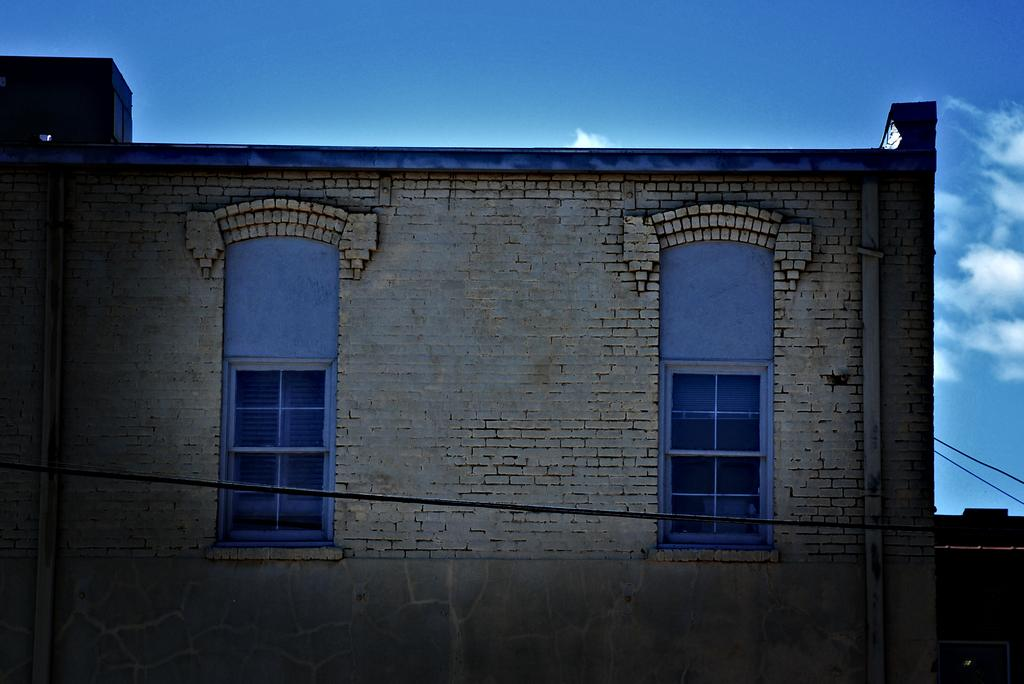What type of structure is visible in the image? There is a building with windows in the image. What can be seen in the background of the image? The sky is visible in the background of the image. Can you describe the object on the right side of the image? Unfortunately, the provided facts do not give enough information to describe the object on the right side of the image. How many giants can be seen walking in the image? There are no giants present in the image. What type of drop can be seen falling from the sky in the image? There is no drop falling from the sky in the image. 